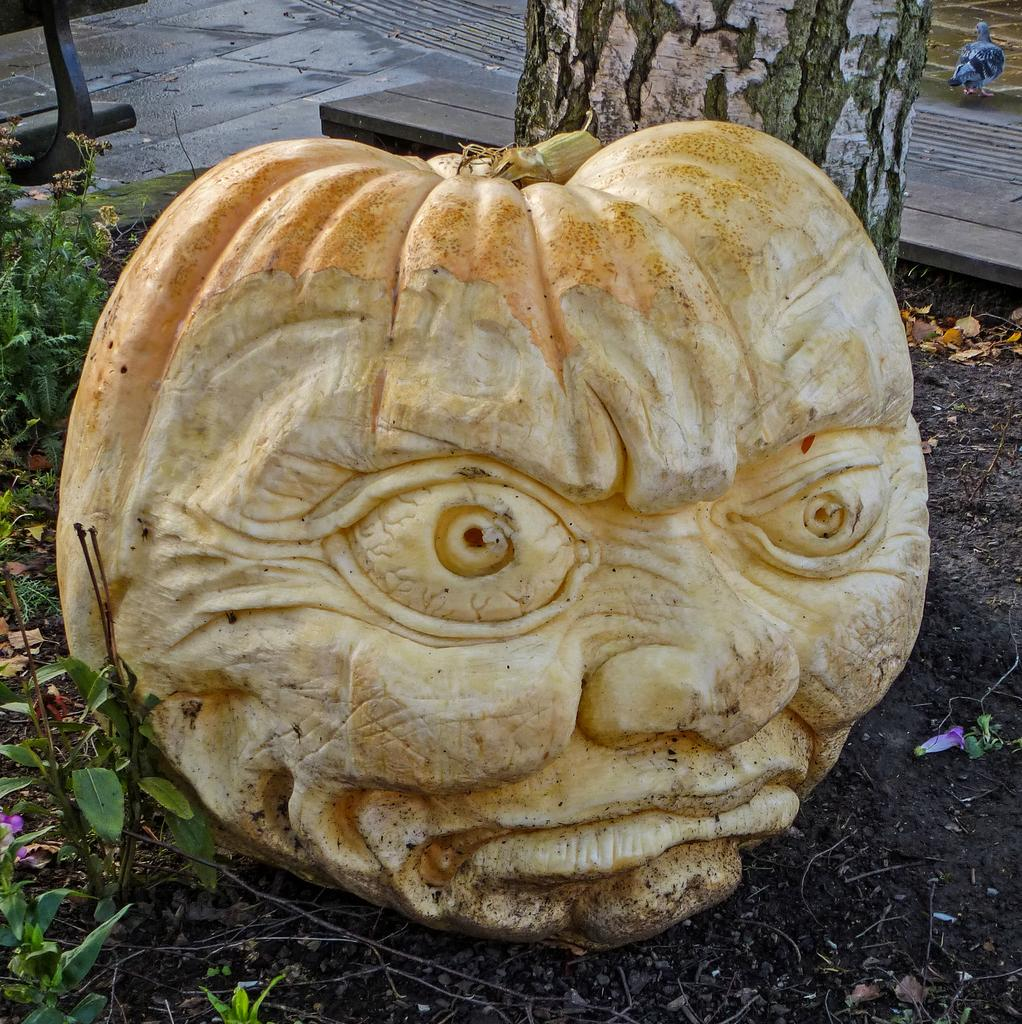What is the main subject in the center of the image? There is a pumpkin in the center of the image. What is unique about the appearance of the pumpkin? The pumpkin has a human face carved on it. What can be seen in the background of the image? There is a bird, a tree, and grass in the background of the image. How does the pencil contribute to the pumpkin's design in the image? There is no pencil present in the image; the pumpkin's design is created by carving a human face into it. 